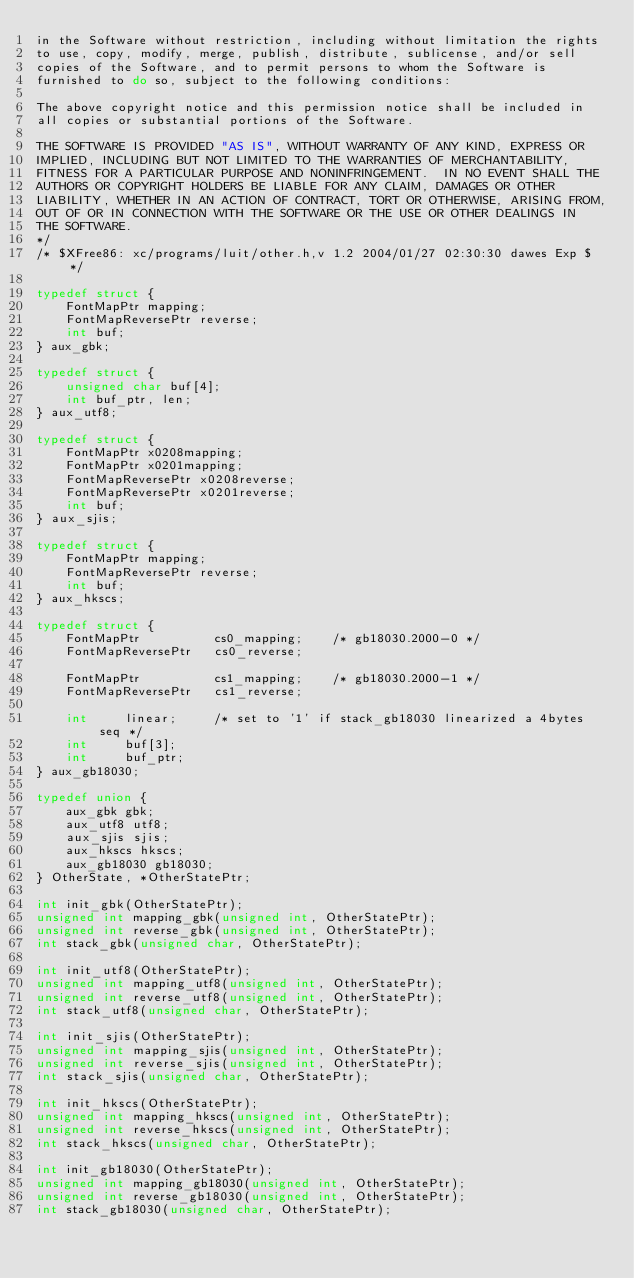Convert code to text. <code><loc_0><loc_0><loc_500><loc_500><_C_>in the Software without restriction, including without limitation the rights
to use, copy, modify, merge, publish, distribute, sublicense, and/or sell
copies of the Software, and to permit persons to whom the Software is
furnished to do so, subject to the following conditions:

The above copyright notice and this permission notice shall be included in
all copies or substantial portions of the Software.

THE SOFTWARE IS PROVIDED "AS IS", WITHOUT WARRANTY OF ANY KIND, EXPRESS OR
IMPLIED, INCLUDING BUT NOT LIMITED TO THE WARRANTIES OF MERCHANTABILITY,
FITNESS FOR A PARTICULAR PURPOSE AND NONINFRINGEMENT.  IN NO EVENT SHALL THE
AUTHORS OR COPYRIGHT HOLDERS BE LIABLE FOR ANY CLAIM, DAMAGES OR OTHER
LIABILITY, WHETHER IN AN ACTION OF CONTRACT, TORT OR OTHERWISE, ARISING FROM,
OUT OF OR IN CONNECTION WITH THE SOFTWARE OR THE USE OR OTHER DEALINGS IN
THE SOFTWARE.
*/
/* $XFree86: xc/programs/luit/other.h,v 1.2 2004/01/27 02:30:30 dawes Exp $ */

typedef struct {
    FontMapPtr mapping;
    FontMapReversePtr reverse;
    int buf;
} aux_gbk;

typedef struct {
    unsigned char buf[4];
    int buf_ptr, len;
} aux_utf8;

typedef struct {
    FontMapPtr x0208mapping;
    FontMapPtr x0201mapping;
    FontMapReversePtr x0208reverse;
    FontMapReversePtr x0201reverse;
    int buf;
} aux_sjis;

typedef struct {
    FontMapPtr mapping;
    FontMapReversePtr reverse;
    int buf;
} aux_hkscs;

typedef struct {
    FontMapPtr          cs0_mapping;    /* gb18030.2000-0 */
    FontMapReversePtr   cs0_reverse;

    FontMapPtr          cs1_mapping;    /* gb18030.2000-1 */
    FontMapReversePtr   cs1_reverse;

    int     linear;     /* set to '1' if stack_gb18030 linearized a 4bytes seq */
    int     buf[3];
    int     buf_ptr;
} aux_gb18030;

typedef union {
    aux_gbk gbk;
    aux_utf8 utf8;
    aux_sjis sjis;
    aux_hkscs hkscs;
    aux_gb18030 gb18030;
} OtherState, *OtherStatePtr;

int init_gbk(OtherStatePtr);
unsigned int mapping_gbk(unsigned int, OtherStatePtr);
unsigned int reverse_gbk(unsigned int, OtherStatePtr);
int stack_gbk(unsigned char, OtherStatePtr);

int init_utf8(OtherStatePtr);
unsigned int mapping_utf8(unsigned int, OtherStatePtr);
unsigned int reverse_utf8(unsigned int, OtherStatePtr);
int stack_utf8(unsigned char, OtherStatePtr);

int init_sjis(OtherStatePtr);
unsigned int mapping_sjis(unsigned int, OtherStatePtr);
unsigned int reverse_sjis(unsigned int, OtherStatePtr);
int stack_sjis(unsigned char, OtherStatePtr);

int init_hkscs(OtherStatePtr);
unsigned int mapping_hkscs(unsigned int, OtherStatePtr);
unsigned int reverse_hkscs(unsigned int, OtherStatePtr);
int stack_hkscs(unsigned char, OtherStatePtr);

int init_gb18030(OtherStatePtr);
unsigned int mapping_gb18030(unsigned int, OtherStatePtr);
unsigned int reverse_gb18030(unsigned int, OtherStatePtr);
int stack_gb18030(unsigned char, OtherStatePtr);

</code> 